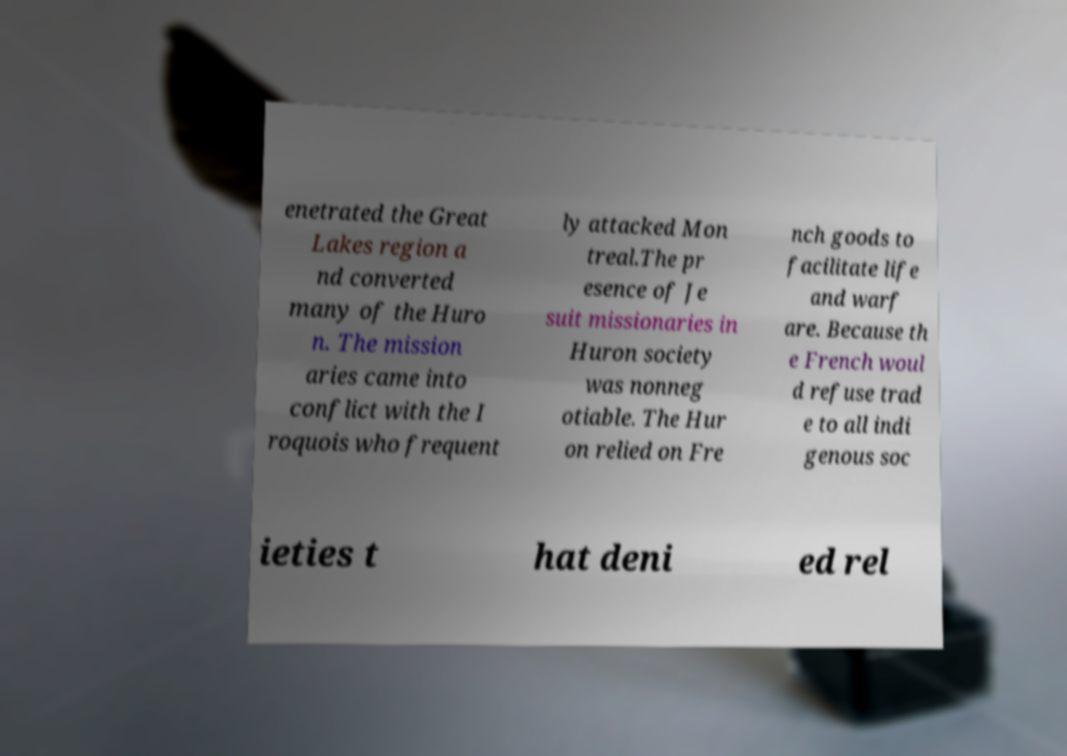Can you read and provide the text displayed in the image?This photo seems to have some interesting text. Can you extract and type it out for me? enetrated the Great Lakes region a nd converted many of the Huro n. The mission aries came into conflict with the I roquois who frequent ly attacked Mon treal.The pr esence of Je suit missionaries in Huron society was nonneg otiable. The Hur on relied on Fre nch goods to facilitate life and warf are. Because th e French woul d refuse trad e to all indi genous soc ieties t hat deni ed rel 